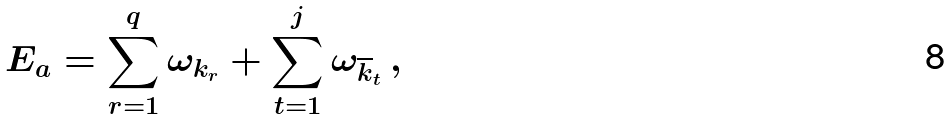Convert formula to latex. <formula><loc_0><loc_0><loc_500><loc_500>E _ { a } = \sum _ { r = 1 } ^ { q } \omega _ { k _ { r } } + \sum _ { t = 1 } ^ { j } \omega _ { \overline { k } _ { t } } \, ,</formula> 